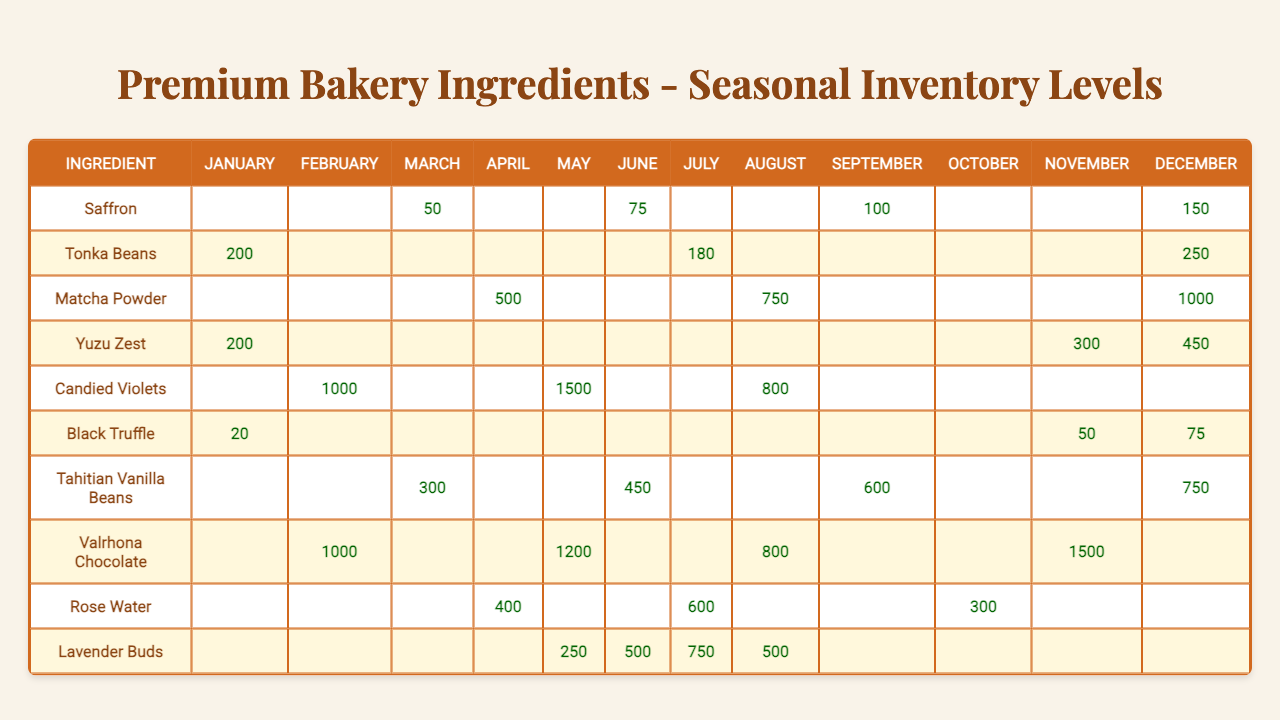What is the inventory level of Saffron in June? According to the table, Saffron has an inventory level of 75 in June.
Answer: 75 How many ingredients have inventory levels recorded for December? The inventory levels for December are recorded for Saffron, Tonka Beans, Matcha Powder, Yuzu Zest, Black Truffle, Tahitian Vanilla Beans, and Valrhona Chocolate, making a total of 7 ingredients.
Answer: 7 Which ingredient has the highest inventory level in February? The table shows that both Candied Violets and Valrhona Chocolate have an inventory level of 1000 in February. Since both have the same value, they are considered equal for this question.
Answer: Candied Violets and Valrhona Chocolate What is the total inventory of Matcha Powder across all listed months? The inventory levels of Matcha Powder are 500 in April, 750 in August, and 1000 in December. Adding these values gives 500 + 750 + 1000 = 2250.
Answer: 2250 Is the inventory of Black Truffle higher in December than in January? In December, Black Truffle has an inventory of 75, while in January it only has 20. Since 75 is greater than 20, the statement is true.
Answer: Yes What is the average inventory level of Candied Violets over the recorded months? Candied Violets' inventory levels are 1000 in February, 1500 in May, and 800 in August. The total is 1000 + 1500 + 800 = 3300; dividing by 3 gives an average of 3300 / 3 = 1100.
Answer: 1100 Which month has the highest combined inventory across all ingredients? The inventory levels must be summed for each month. For example, in December: Saffron (150), Tonka Beans (250), Matcha Powder (1000), etc. Upon checking, December has the highest sum of 3225.
Answer: December How much more Yuzu Zest is available in December than in November? The inventory level of Yuzu Zest is 450 in December and 300 in November. The difference is calculated as 450 - 300 = 150.
Answer: 150 Which ingredient has consistent inventory levels throughout the year? Looking at the table, there are no ingredients with inventory reported in every month; thus, no ingredient meets this criterion.
Answer: No What is the total inventory for Valrhona Chocolate for the months it’s recorded? Valrhona Chocolate's inventory levels are 1000 in February, 1200 in May, 800 in August, and 1500 in November. Summing these values gives 1000 + 1200 + 800 + 1500 = 3500.
Answer: 3500 